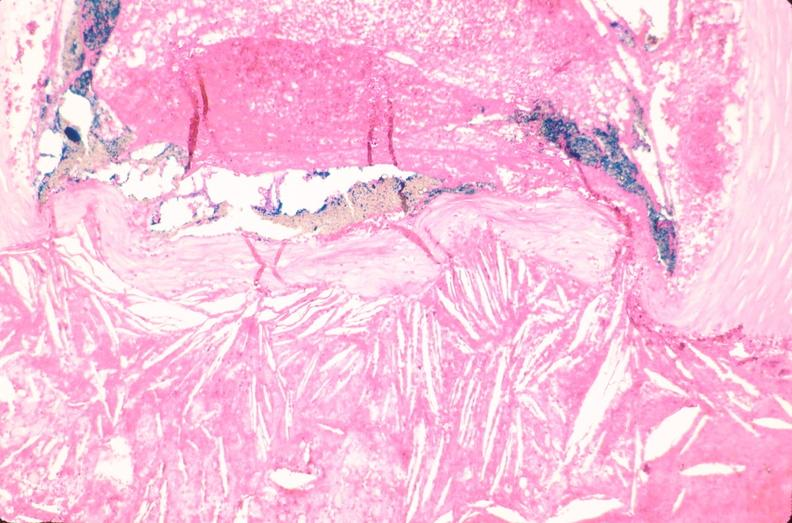does this image show coronary artery atherosclerosis?
Answer the question using a single word or phrase. Yes 